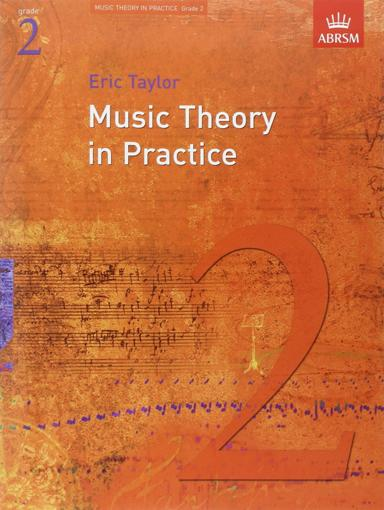What organization is associated with the book? The book is associated with the ABRSM (Associated Board of the Royal Schools of Music), an esteemed organization that provides assessments and resources for music learners. Eric Taylor's book is part of a series tailored to adhere to the ABRSM's syllabus requirements. 